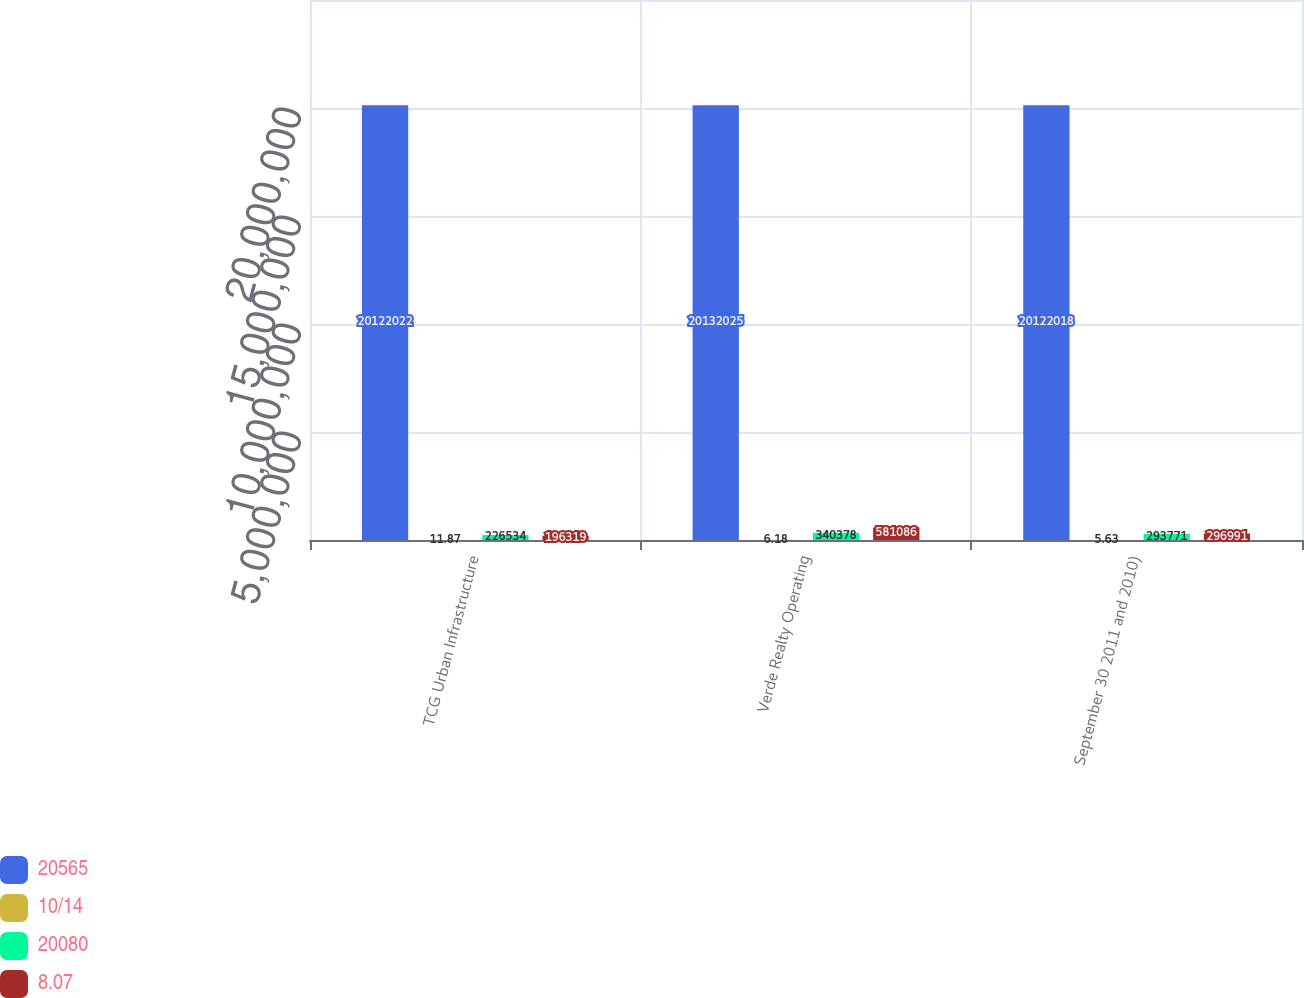Convert chart to OTSL. <chart><loc_0><loc_0><loc_500><loc_500><stacked_bar_chart><ecel><fcel>TCG Urban Infrastructure<fcel>Verde Realty Operating<fcel>September 30 2011 and 2010)<nl><fcel>20565<fcel>2.0122e+07<fcel>2.0132e+07<fcel>2.0122e+07<nl><fcel>10/14<fcel>11.87<fcel>6.18<fcel>5.63<nl><fcel>20080<fcel>226534<fcel>340378<fcel>293771<nl><fcel>8.07<fcel>196319<fcel>581086<fcel>296991<nl></chart> 